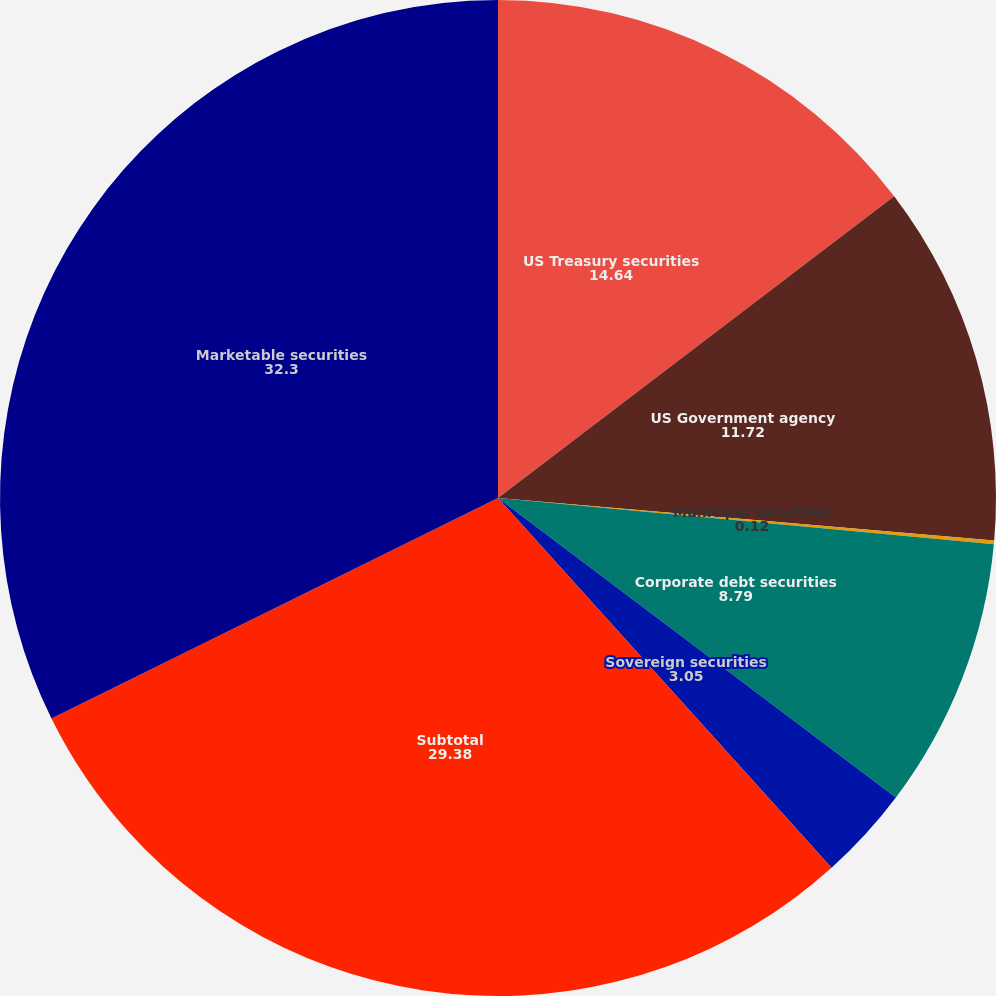Convert chart. <chart><loc_0><loc_0><loc_500><loc_500><pie_chart><fcel>US Treasury securities<fcel>US Government agency<fcel>Municipal securities<fcel>Corporate debt securities<fcel>Sovereign securities<fcel>Subtotal<fcel>Marketable securities<nl><fcel>14.64%<fcel>11.72%<fcel>0.12%<fcel>8.79%<fcel>3.05%<fcel>29.38%<fcel>32.3%<nl></chart> 